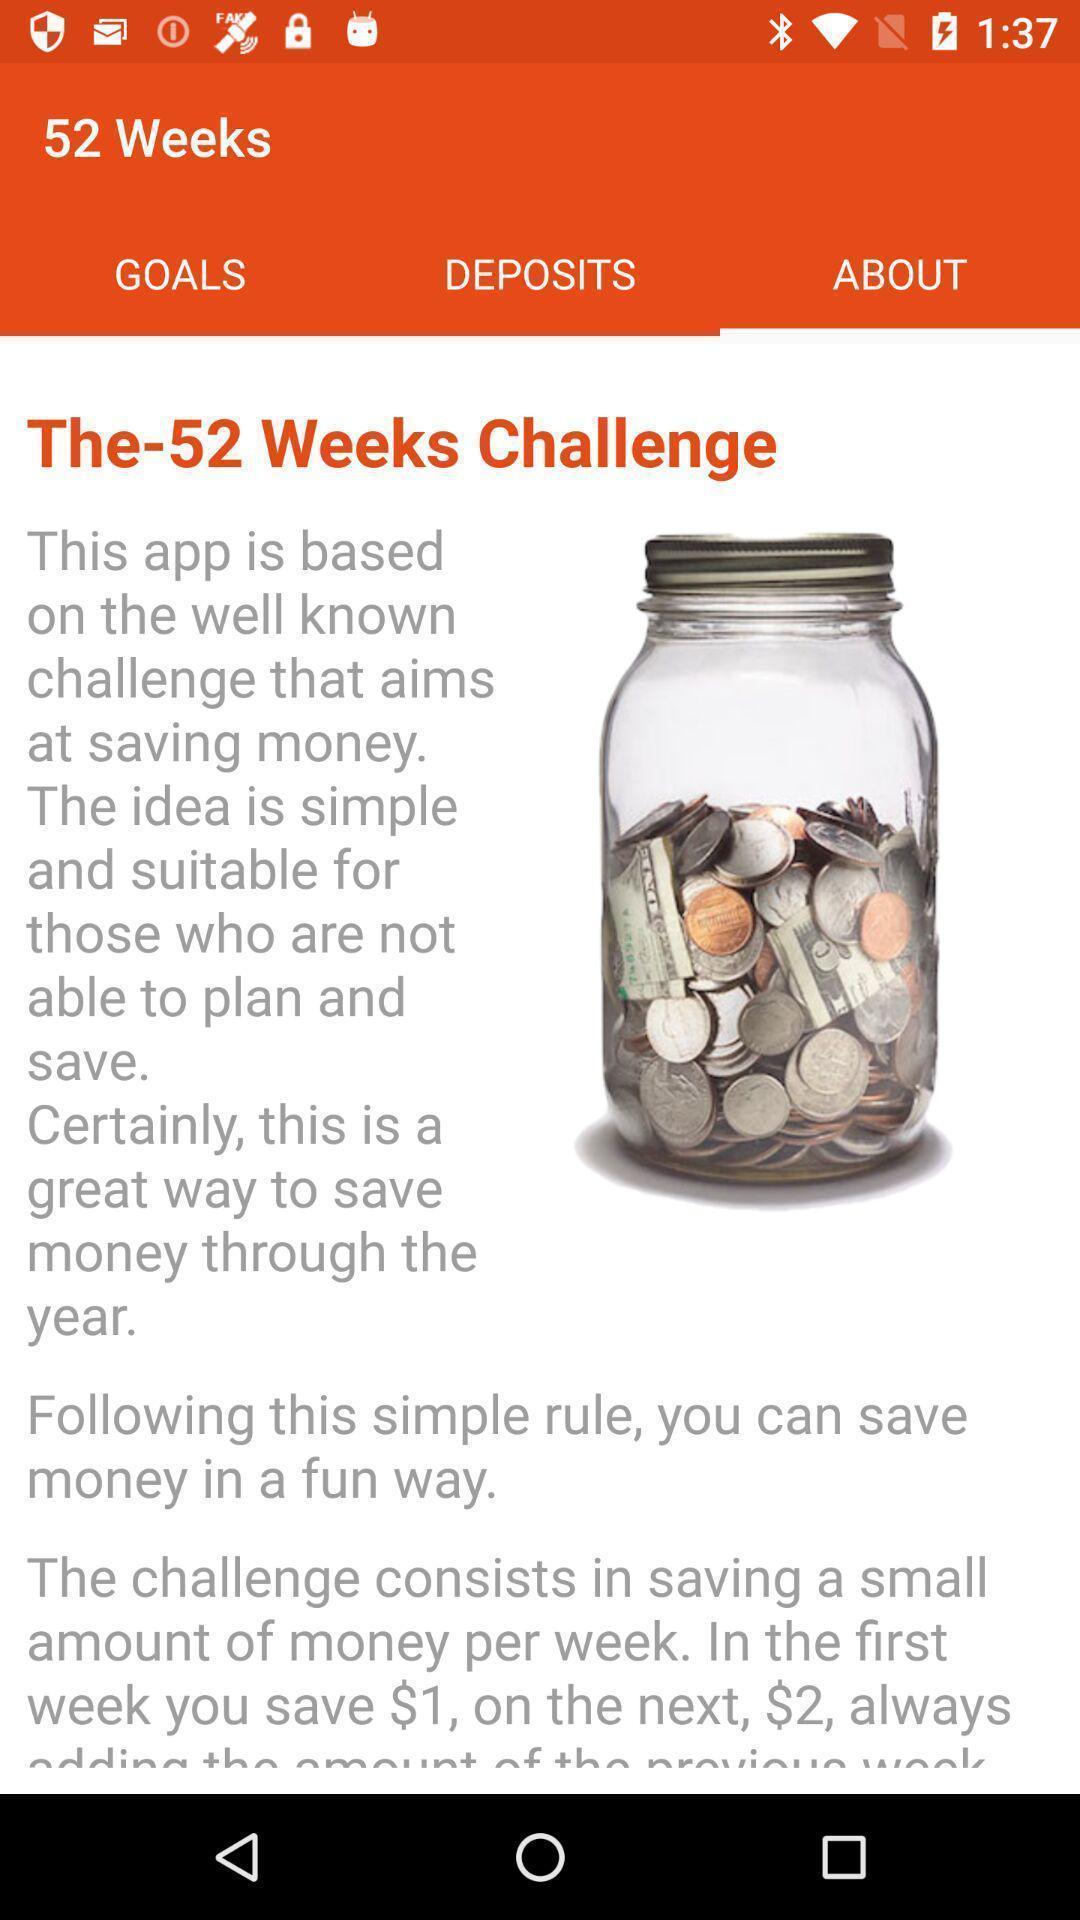Provide a description of this screenshot. Week challenges in the application with description. 